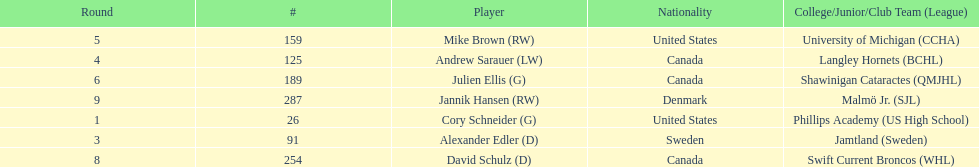How many goalies drafted? 2. 